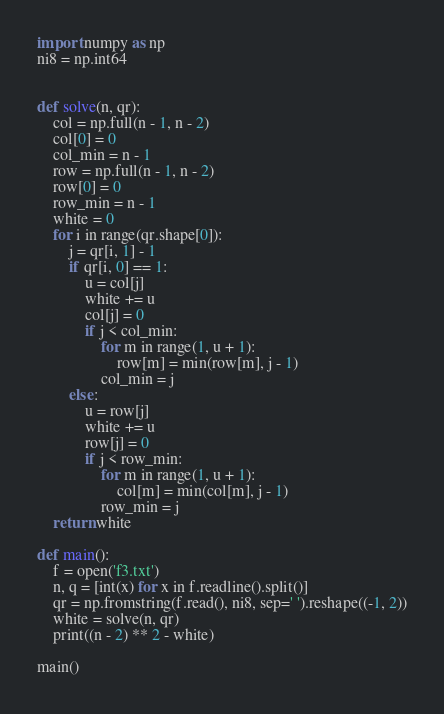Convert code to text. <code><loc_0><loc_0><loc_500><loc_500><_Python_>import numpy as np
ni8 = np.int64


def solve(n, qr):
    col = np.full(n - 1, n - 2)
    col[0] = 0
    col_min = n - 1
    row = np.full(n - 1, n - 2)
    row[0] = 0
    row_min = n - 1
    white = 0
    for i in range(qr.shape[0]):
        j = qr[i, 1] - 1
        if qr[i, 0] == 1:
            u = col[j]
            white += u
            col[j] = 0
            if j < col_min:
                for m in range(1, u + 1):
                    row[m] = min(row[m], j - 1)
                col_min = j
        else:
            u = row[j]
            white += u
            row[j] = 0
            if j < row_min:
                for m in range(1, u + 1):
                    col[m] = min(col[m], j - 1)
                row_min = j
    return white

def main():
    f = open('f3.txt')
    n, q = [int(x) for x in f.readline().split()]
    qr = np.fromstring(f.read(), ni8, sep=' ').reshape((-1, 2))
    white = solve(n, qr)
    print((n - 2) ** 2 - white)

main()</code> 